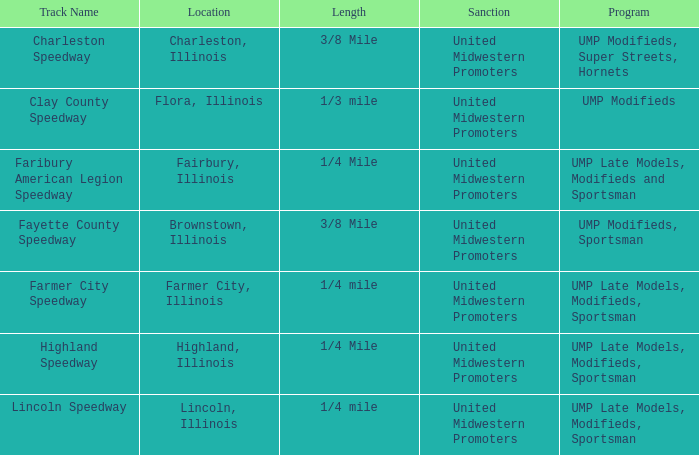Who sanctioned the event in lincoln, illinois? United Midwestern Promoters. 